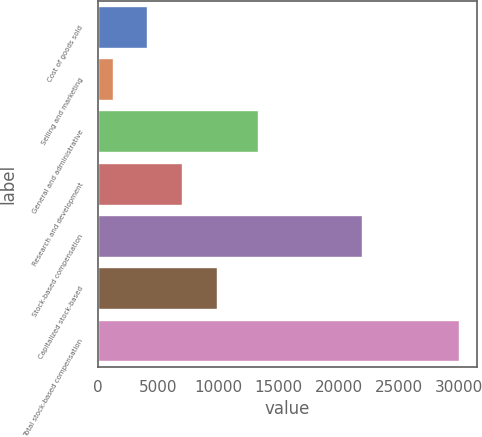<chart> <loc_0><loc_0><loc_500><loc_500><bar_chart><fcel>Cost of goods sold<fcel>Selling and marketing<fcel>General and administrative<fcel>Research and development<fcel>Stock-based compensation<fcel>Capitalized stock-based<fcel>Total stock-based compensation<nl><fcel>4131.9<fcel>1256<fcel>13277<fcel>7007.8<fcel>21931<fcel>9883.7<fcel>30015<nl></chart> 